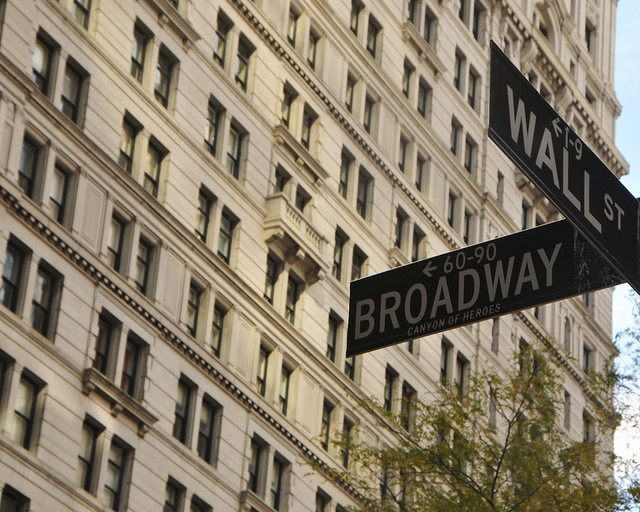Read all the text in this image. BROADWAY WALL ST 60 90 HEROES OF CANYON 6 1 